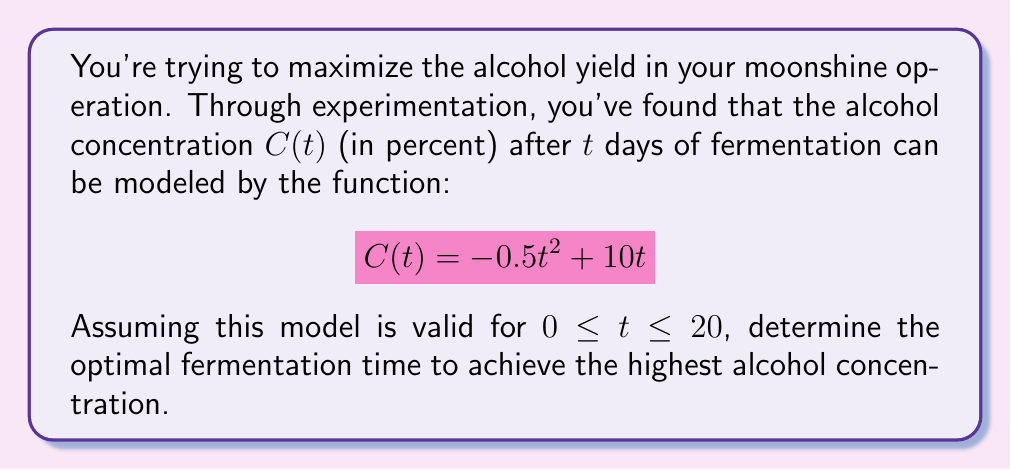Give your solution to this math problem. To find the optimal fermentation time, we need to maximize the function $C(t)$. This is an optimization problem that can be solved using calculus.

1. First, we find the derivative of $C(t)$:
   $$C'(t) = -t + 10$$

2. To find the maximum, we set the derivative equal to zero and solve for $t$:
   $$-t + 10 = 0$$
   $$t = 10$$

3. To confirm this is a maximum (not a minimum), we can check the second derivative:
   $$C''(t) = -1$$
   Since $C''(t)$ is negative, we confirm that $t = 10$ gives a maximum.

4. We should also check the endpoints of our interval (0 and 20 days) to ensure our solution is valid:
   $$C(0) = 0$$
   $$C(10) = -0.5(10)^2 + 10(10) = 50$$
   $$C(20) = -0.5(20)^2 + 10(20) = 0$$

5. The maximum value occurs at $t = 10$, which is within our valid interval and greater than the endpoint values.

Therefore, the optimal fermentation time is 10 days, which will yield a maximum alcohol concentration of 50%.
Answer: The optimal fermentation time is 10 days, yielding a maximum alcohol concentration of 50%. 